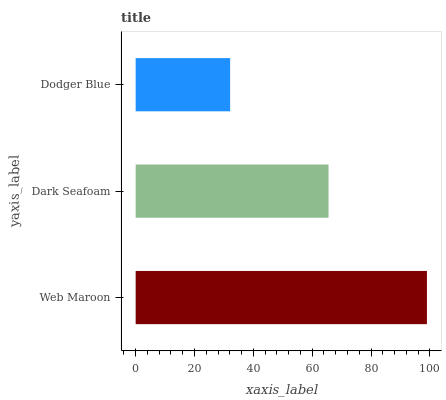Is Dodger Blue the minimum?
Answer yes or no. Yes. Is Web Maroon the maximum?
Answer yes or no. Yes. Is Dark Seafoam the minimum?
Answer yes or no. No. Is Dark Seafoam the maximum?
Answer yes or no. No. Is Web Maroon greater than Dark Seafoam?
Answer yes or no. Yes. Is Dark Seafoam less than Web Maroon?
Answer yes or no. Yes. Is Dark Seafoam greater than Web Maroon?
Answer yes or no. No. Is Web Maroon less than Dark Seafoam?
Answer yes or no. No. Is Dark Seafoam the high median?
Answer yes or no. Yes. Is Dark Seafoam the low median?
Answer yes or no. Yes. Is Web Maroon the high median?
Answer yes or no. No. Is Web Maroon the low median?
Answer yes or no. No. 